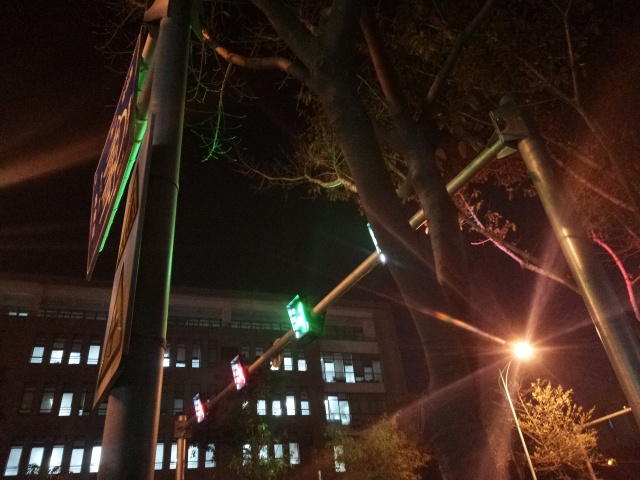What does this photo capture?
A. The photo captures a building and a tree.
B. The photo captures a traffic light and a road sign.
C. The photo captures a car and a pedestrian.
D. The photo captures a bicycle and a bench.
Answer with the option's letter from the given choices directly.
 B. 